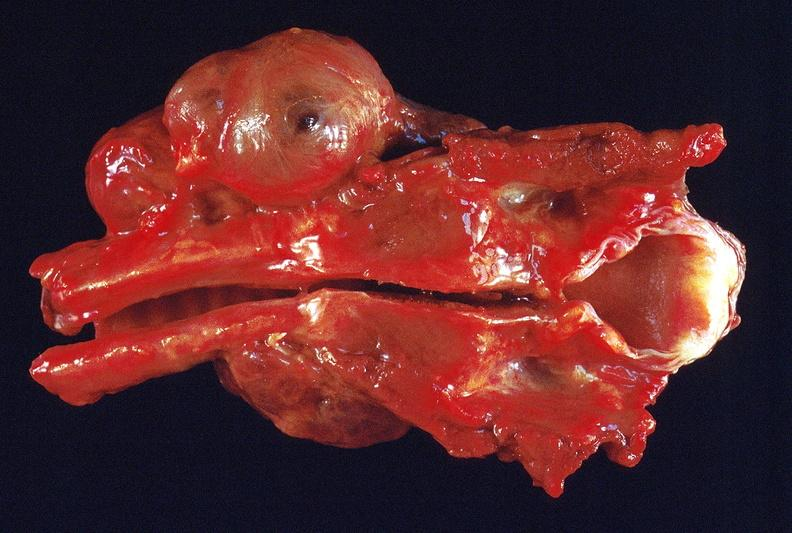s case of peritonitis slide present?
Answer the question using a single word or phrase. No 